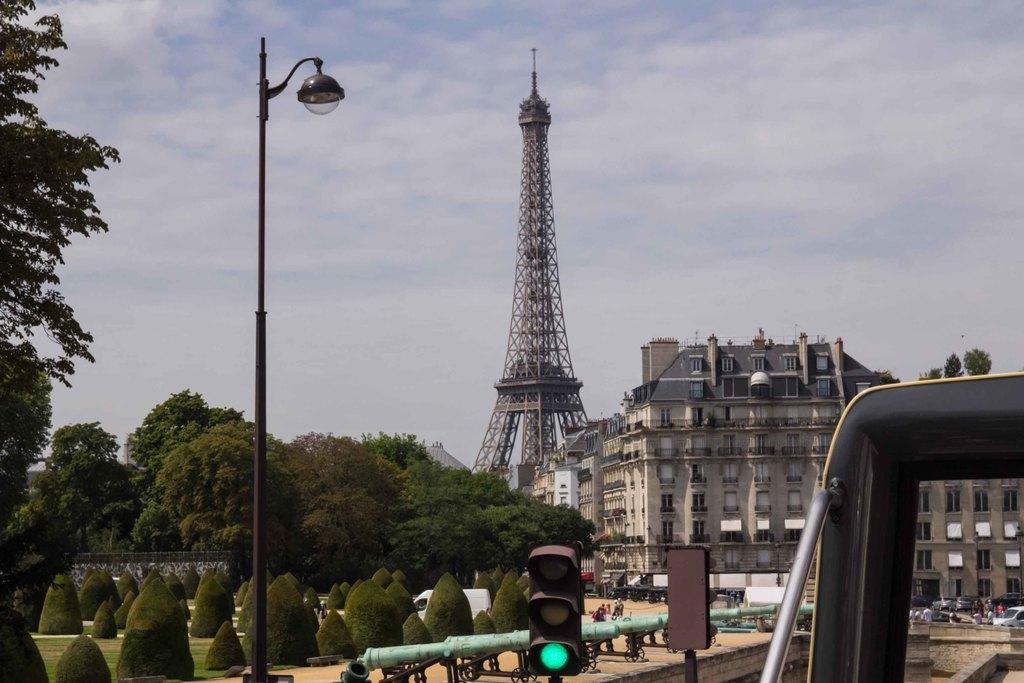What types of living organisms can be seen in the image? The image contains trees and plants. Where is the vehicle located in the image? The vehicle is on the right side of the image. What can be seen in the background of the image? There is a tower and buildings in the background of the image. What is the object at the bottom of the image? There is a signal pole at the bottom of the image. Can you tell me how many owls are perched on the signal pole in the image? There are no owls present in the image; the signal pole is the only object at the bottom of the image. What type of bird can be seen flying over the tower in the image? There are no birds visible in the image; only trees, plants, a vehicle, a tower, buildings, and a signal pole are present. 